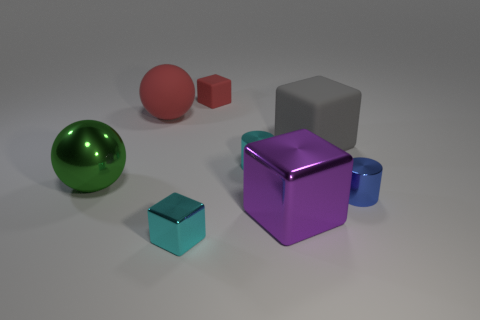Add 1 large gray metal cylinders. How many objects exist? 9 Subtract all cylinders. How many objects are left? 6 Subtract all red blocks. Subtract all small red cubes. How many objects are left? 6 Add 7 red rubber objects. How many red rubber objects are left? 9 Add 6 cyan shiny blocks. How many cyan shiny blocks exist? 7 Subtract 1 blue cylinders. How many objects are left? 7 